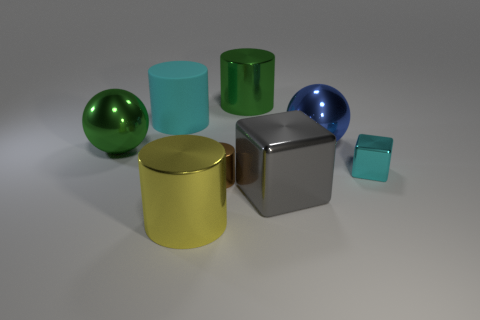Add 1 tiny cyan shiny cylinders. How many objects exist? 9 Subtract all gray cylinders. Subtract all cyan balls. How many cylinders are left? 4 Subtract all spheres. How many objects are left? 6 Add 5 big green shiny things. How many big green shiny things are left? 7 Add 6 yellow metal cylinders. How many yellow metal cylinders exist? 7 Subtract 0 brown spheres. How many objects are left? 8 Subtract all green spheres. Subtract all big gray cubes. How many objects are left? 6 